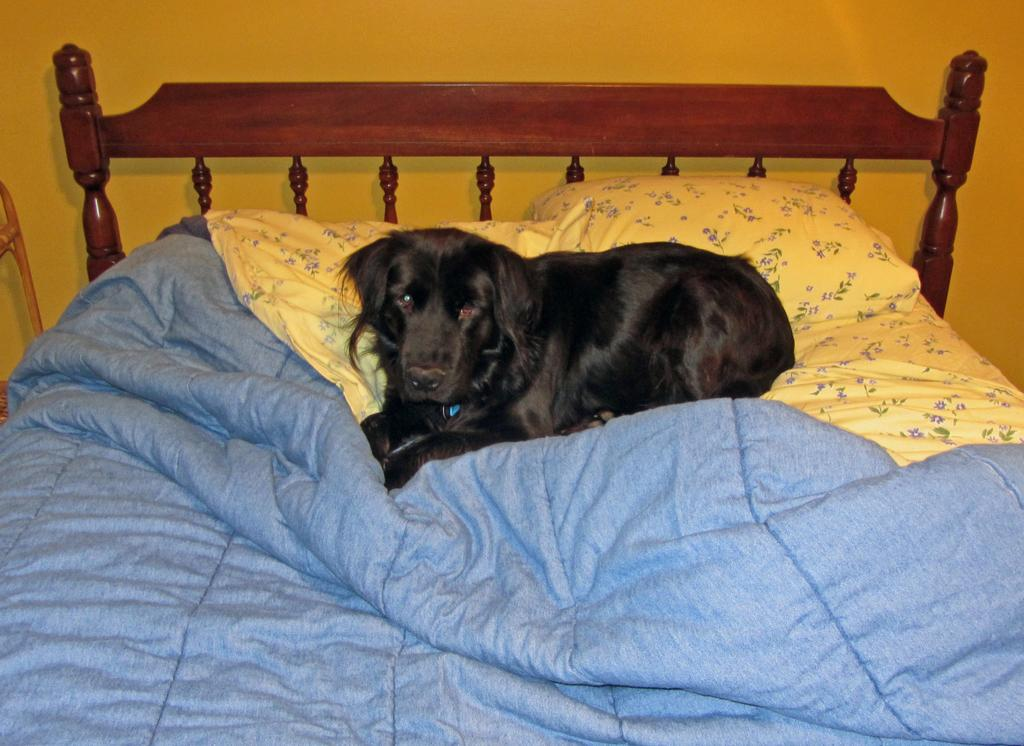Where was the image taken? The image was taken in a room. What furniture is present in the room? There is a bed in the room. What accessories are on the bed? There are pillows and a blanket on the bed. What type of animal is on the bed? There is a dog on the bed. What color is the wall at the top of the room? The wall at the top of the room is painted yellow. What theory is the dog testing in the image? There is no indication in the image that the dog is testing any theory. What type of toys can be seen on the bed? There are no toys visible on the bed in the image. 